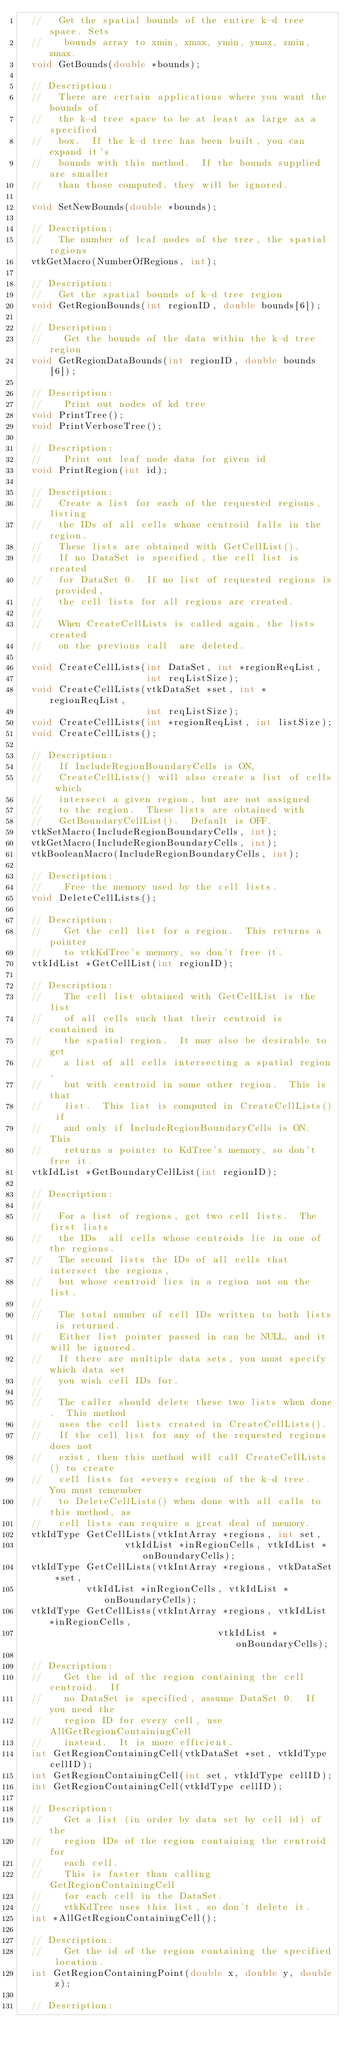Convert code to text. <code><loc_0><loc_0><loc_500><loc_500><_C_>  //   Get the spatial bounds of the entire k-d tree space. Sets
  //    bounds array to xmin, xmax, ymin, ymax, zmin, zmax.
  void GetBounds(double *bounds);

  // Description:
  //   There are certain applications where you want the bounds of
  //   the k-d tree space to be at least as large as a specified
  //   box.  If the k-d tree has been built, you can expand it's 
  //   bounds with this method.  If the bounds supplied are smaller
  //   than those computed, they will be ignored.

  void SetNewBounds(double *bounds);

  // Description:
  //   The number of leaf nodes of the tree, the spatial regions
  vtkGetMacro(NumberOfRegions, int);

  // Description:
  //   Get the spatial bounds of k-d tree region
  void GetRegionBounds(int regionID, double bounds[6]);

  // Description:
  //    Get the bounds of the data within the k-d tree region
  void GetRegionDataBounds(int regionID, double bounds[6]);

  // Description:
  //    Print out nodes of kd tree
  void PrintTree();
  void PrintVerboseTree();
  
  // Description:
  //    Print out leaf node data for given id
  void PrintRegion(int id);
  
  // Description:
  //   Create a list for each of the requested regions, listing
  //   the IDs of all cells whose centroid falls in the region.
  //   These lists are obtained with GetCellList().
  //   If no DataSet is specified, the cell list is created
  //   for DataSet 0.  If no list of requested regions is provided,
  //   the cell lists for all regions are created.  
  //
  //   When CreateCellLists is called again, the lists created
  //   on the previous call  are deleted.
  
  void CreateCellLists(int DataSet, int *regionReqList, 
                       int reqListSize);
  void CreateCellLists(vtkDataSet *set, int *regionReqList,
                       int reqListSize);
  void CreateCellLists(int *regionReqList, int listSize);
  void CreateCellLists(); 
  
  // Description:
  //   If IncludeRegionBoundaryCells is ON,
  //   CreateCellLists() will also create a list of cells which
  //   intersect a given region, but are not assigned
  //   to the region.  These lists are obtained with 
  //   GetBoundaryCellList().  Default is OFF.
  vtkSetMacro(IncludeRegionBoundaryCells, int);
  vtkGetMacro(IncludeRegionBoundaryCells, int);
  vtkBooleanMacro(IncludeRegionBoundaryCells, int);

  // Description:
  //    Free the memory used by the cell lists.
  void DeleteCellLists();

  // Description:
  //    Get the cell list for a region.  This returns a pointer
  //    to vtkKdTree's memory, so don't free it.
  vtkIdList *GetCellList(int regionID);

  // Description:
  //    The cell list obtained with GetCellList is the list
  //    of all cells such that their centroid is contained in
  //    the spatial region.  It may also be desirable to get
  //    a list of all cells intersecting a spatial region,
  //    but with centroid in some other region.  This is that
  //    list.  This list is computed in CreateCellLists() if
  //    and only if IncludeRegionBoundaryCells is ON.  This
  //    returns a pointer to KdTree's memory, so don't free it.
  vtkIdList *GetBoundaryCellList(int regionID);

  // Description:
  //   
  //   For a list of regions, get two cell lists.  The first lists
  //   the IDs  all cells whose centroids lie in one of the regions.
  //   The second lists the IDs of all cells that intersect the regions,
  //   but whose centroid lies in a region not on the list.
  //
  //   The total number of cell IDs written to both lists is returned.
  //   Either list pointer passed in can be NULL, and it will be ignored.
  //   If there are multiple data sets, you must specify which data set
  //   you wish cell IDs for.
  //
  //   The caller should delete these two lists when done.  This method
  //   uses the cell lists created in CreateCellLists().
  //   If the cell list for any of the requested regions does not
  //   exist, then this method will call CreateCellLists() to create
  //   cell lists for *every* region of the k-d tree.  You must remember 
  //   to DeleteCellLists() when done with all calls to this method, as 
  //   cell lists can require a great deal of memory.
  vtkIdType GetCellLists(vtkIntArray *regions, int set, 
                   vtkIdList *inRegionCells, vtkIdList *onBoundaryCells);
  vtkIdType GetCellLists(vtkIntArray *regions, vtkDataSet *set,
            vtkIdList *inRegionCells, vtkIdList *onBoundaryCells);
  vtkIdType GetCellLists(vtkIntArray *regions, vtkIdList *inRegionCells,
                                    vtkIdList *onBoundaryCells);
  
  // Description:
  //    Get the id of the region containing the cell centroid.  If
  //    no DataSet is specified, assume DataSet 0.  If you need the
  //    region ID for every cell, use AllGetRegionContainingCell
  //    instead.  It is more efficient.
  int GetRegionContainingCell(vtkDataSet *set, vtkIdType cellID);
  int GetRegionContainingCell(int set, vtkIdType cellID);
  int GetRegionContainingCell(vtkIdType cellID);

  // Description:
  //    Get a list (in order by data set by cell id) of the
  //    region IDs of the region containing the centroid for
  //    each cell.
  //    This is faster than calling GetRegionContainingCell
  //    for each cell in the DataSet.
  //    vtkKdTree uses this list, so don't delete it.
  int *AllGetRegionContainingCell();

  // Description:
  //    Get the id of the region containing the specified location.
  int GetRegionContainingPoint(double x, double y, double z);
  
  // Description:</code> 